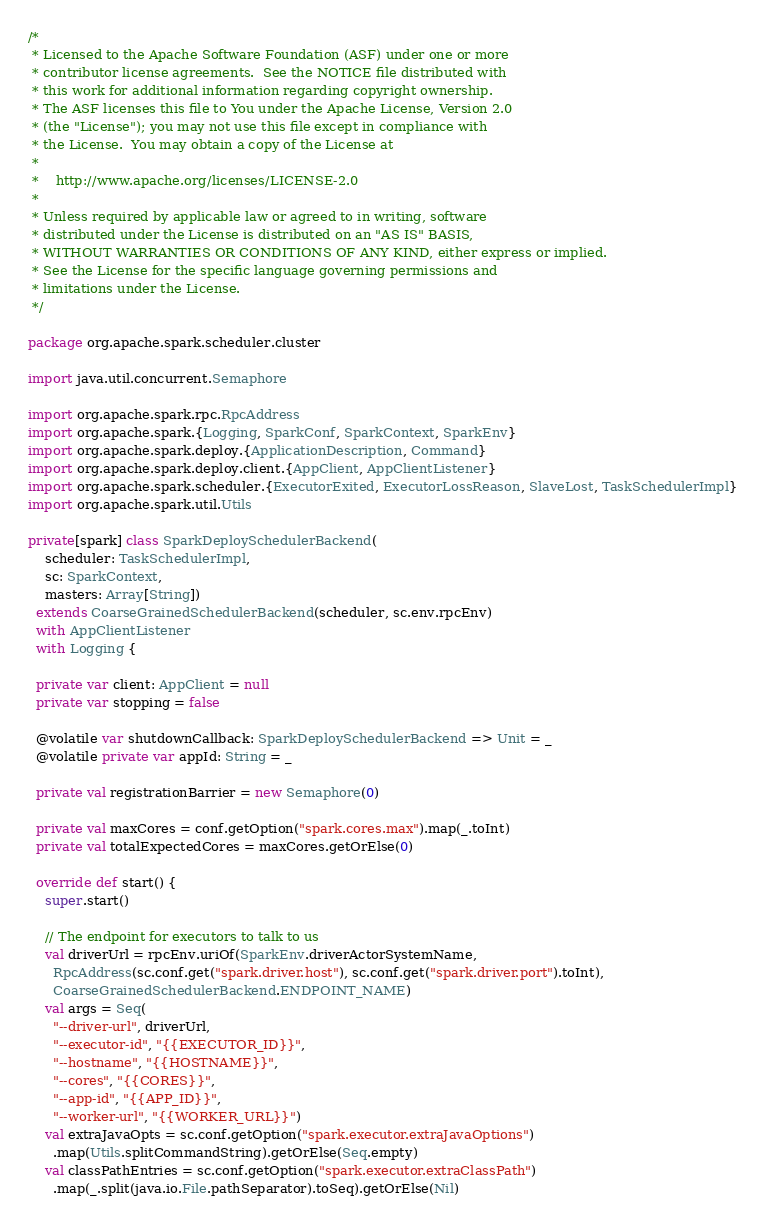<code> <loc_0><loc_0><loc_500><loc_500><_Scala_>/*
 * Licensed to the Apache Software Foundation (ASF) under one or more
 * contributor license agreements.  See the NOTICE file distributed with
 * this work for additional information regarding copyright ownership.
 * The ASF licenses this file to You under the Apache License, Version 2.0
 * (the "License"); you may not use this file except in compliance with
 * the License.  You may obtain a copy of the License at
 *
 *    http://www.apache.org/licenses/LICENSE-2.0
 *
 * Unless required by applicable law or agreed to in writing, software
 * distributed under the License is distributed on an "AS IS" BASIS,
 * WITHOUT WARRANTIES OR CONDITIONS OF ANY KIND, either express or implied.
 * See the License for the specific language governing permissions and
 * limitations under the License.
 */

package org.apache.spark.scheduler.cluster

import java.util.concurrent.Semaphore

import org.apache.spark.rpc.RpcAddress
import org.apache.spark.{Logging, SparkConf, SparkContext, SparkEnv}
import org.apache.spark.deploy.{ApplicationDescription, Command}
import org.apache.spark.deploy.client.{AppClient, AppClientListener}
import org.apache.spark.scheduler.{ExecutorExited, ExecutorLossReason, SlaveLost, TaskSchedulerImpl}
import org.apache.spark.util.Utils

private[spark] class SparkDeploySchedulerBackend(
    scheduler: TaskSchedulerImpl,
    sc: SparkContext,
    masters: Array[String])
  extends CoarseGrainedSchedulerBackend(scheduler, sc.env.rpcEnv)
  with AppClientListener
  with Logging {

  private var client: AppClient = null
  private var stopping = false

  @volatile var shutdownCallback: SparkDeploySchedulerBackend => Unit = _
  @volatile private var appId: String = _

  private val registrationBarrier = new Semaphore(0)

  private val maxCores = conf.getOption("spark.cores.max").map(_.toInt)
  private val totalExpectedCores = maxCores.getOrElse(0)

  override def start() {
    super.start()

    // The endpoint for executors to talk to us
    val driverUrl = rpcEnv.uriOf(SparkEnv.driverActorSystemName,
      RpcAddress(sc.conf.get("spark.driver.host"), sc.conf.get("spark.driver.port").toInt),
      CoarseGrainedSchedulerBackend.ENDPOINT_NAME)
    val args = Seq(
      "--driver-url", driverUrl,
      "--executor-id", "{{EXECUTOR_ID}}",
      "--hostname", "{{HOSTNAME}}",
      "--cores", "{{CORES}}",
      "--app-id", "{{APP_ID}}",
      "--worker-url", "{{WORKER_URL}}")
    val extraJavaOpts = sc.conf.getOption("spark.executor.extraJavaOptions")
      .map(Utils.splitCommandString).getOrElse(Seq.empty)
    val classPathEntries = sc.conf.getOption("spark.executor.extraClassPath")
      .map(_.split(java.io.File.pathSeparator).toSeq).getOrElse(Nil)</code> 